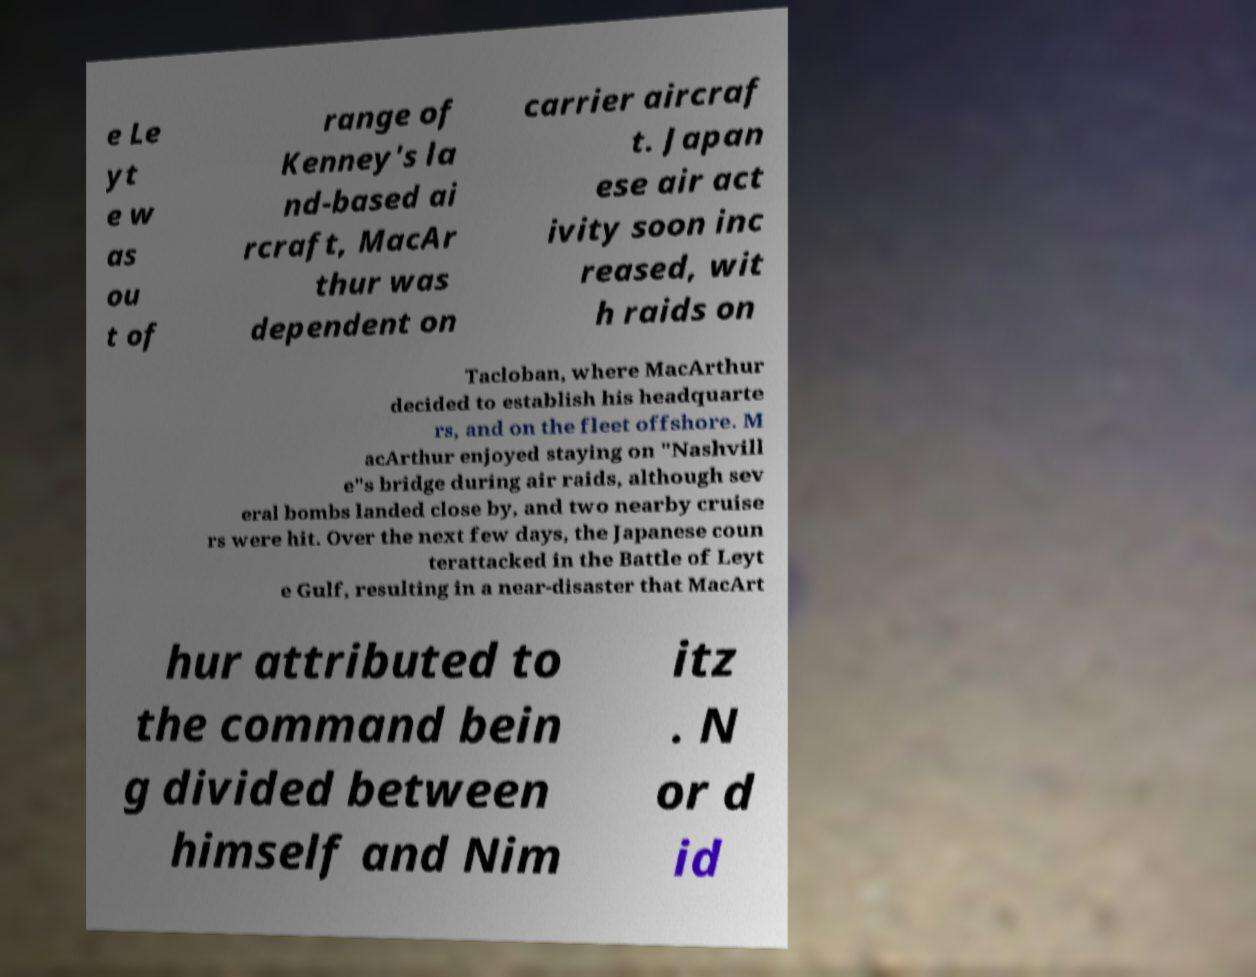For documentation purposes, I need the text within this image transcribed. Could you provide that? e Le yt e w as ou t of range of Kenney's la nd-based ai rcraft, MacAr thur was dependent on carrier aircraf t. Japan ese air act ivity soon inc reased, wit h raids on Tacloban, where MacArthur decided to establish his headquarte rs, and on the fleet offshore. M acArthur enjoyed staying on "Nashvill e"s bridge during air raids, although sev eral bombs landed close by, and two nearby cruise rs were hit. Over the next few days, the Japanese coun terattacked in the Battle of Leyt e Gulf, resulting in a near-disaster that MacArt hur attributed to the command bein g divided between himself and Nim itz . N or d id 